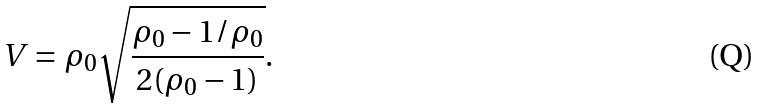<formula> <loc_0><loc_0><loc_500><loc_500>V = \rho _ { 0 } \sqrt { \frac { \rho _ { 0 } - 1 / \rho _ { 0 } } { 2 ( \rho _ { 0 } - 1 ) } } .</formula> 